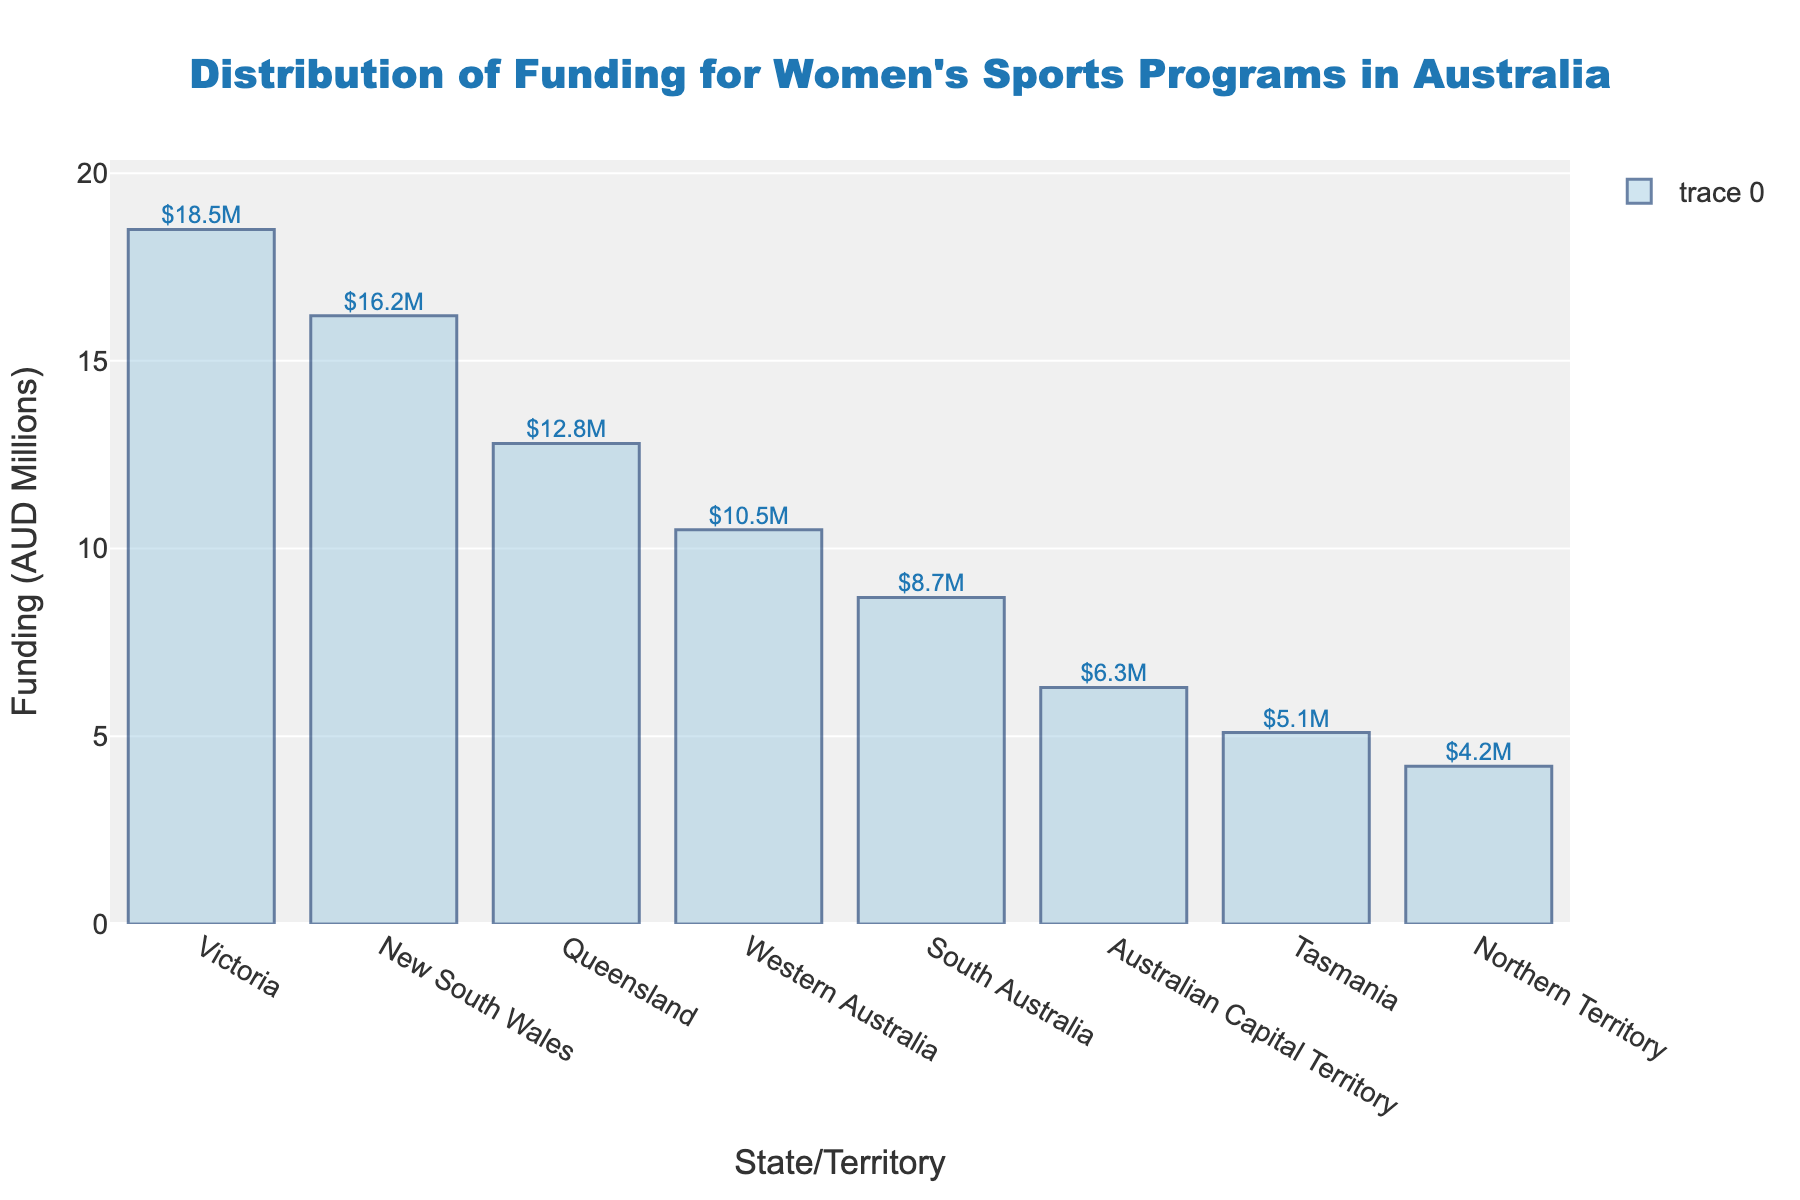Which state receives the highest funding for women's sports programs? By looking at the bar chart, the bar representing Victoria is the tallest, indicating it receives the highest funding.
Answer: Victoria What is the total funding for New South Wales and Queensland combined? New South Wales has 16.2 million AUD and Queensland has 12.8 million AUD. Adding these together, 16.2 + 12.8 = 29 million AUD.
Answer: 29 million AUD Which state receives the least funding, and how much is it? The shortest bar corresponds to the Northern Territory, which receives 4.2 million AUD.
Answer: Northern Territory, 4.2 million AUD Which state receives more funding: South Australia or Western Australia, and by how much? Western Australia receives 10.5 million AUD and South Australia receives 8.7 million AUD. The difference is 10.5 - 8.7 = 1.8 million AUD.
Answer: Western Australia, 1.8 million AUD What is the average funding amount for all the states and territories? The total funding is 82.3 million AUD over 8 states and territories. The average is 82.3 / 8 ≈ 10.29 million AUD.
Answer: ≈ 10.29 million AUD Which states receive more than 10 million AUD in funding? By observing the bars taller than the 10 million AUD mark, they represent Victoria, New South Wales, Queensland, and Western Australia.
Answer: Victoria, New South Wales, Queensland, Western Australia What is the funding difference between the highest-funded state and the lowest-funded state? The highest-funded state is Victoria with 18.5 million AUD, and the lowest-funded is Northern Territory with 4.2 million AUD. The difference is 18.5 - 4.2 = 14.3 million AUD.
Answer: 14.3 million AUD How does the funding for the Australian Capital Territory compare to Tasmania? The bar for the Australian Capital Territory is taller, indicating it receives more funding than Tasmania. Specifically, ACT receives 6.3 million AUD and Tasmania gets 5.1 million AUD.
Answer: Australian Capital Territory receives 1.2 million AUD more than Tasmania What is the median funding amount? The sorted funding amounts are (4.2, 5.1, 6.3, 8.7, 10.5, 12.8, 16.2, 18.5). The median is the average of the 4th and 5th values: (8.7 + 10.5) / 2 = 9.6 million AUD.
Answer: 9.6 million AUD Which states or territories have funding amounts within 1 million AUD of each other? By inspecting the bars closely, Tasmania (5.1 million AUD) and Northern Territory (4.2 million AUD) are within 1 million AUD of each other, as well as South Australia (8.7 million AUD) and Western Australia (10.5 million AUD).
Answer: Tasmania and Northern Territory, South Australia and Western Australia 